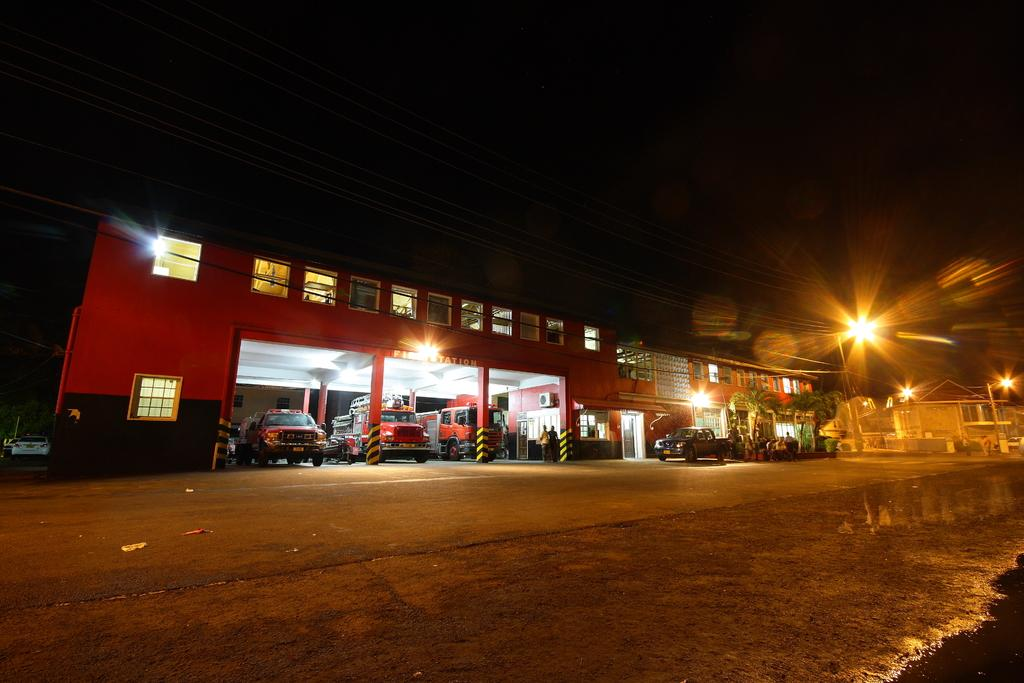What type of structures can be seen in the image? There are buildings in the image. What feature is visible on the buildings? There are windows visible in the image. What else is present in the image besides buildings? Wires, light poles, vehicles, and cars are visible in the image. What is visible in the background of the image? The sky is visible in the image. What type of produce is being glued to the star in the image? There is no star or produce present in the image. 